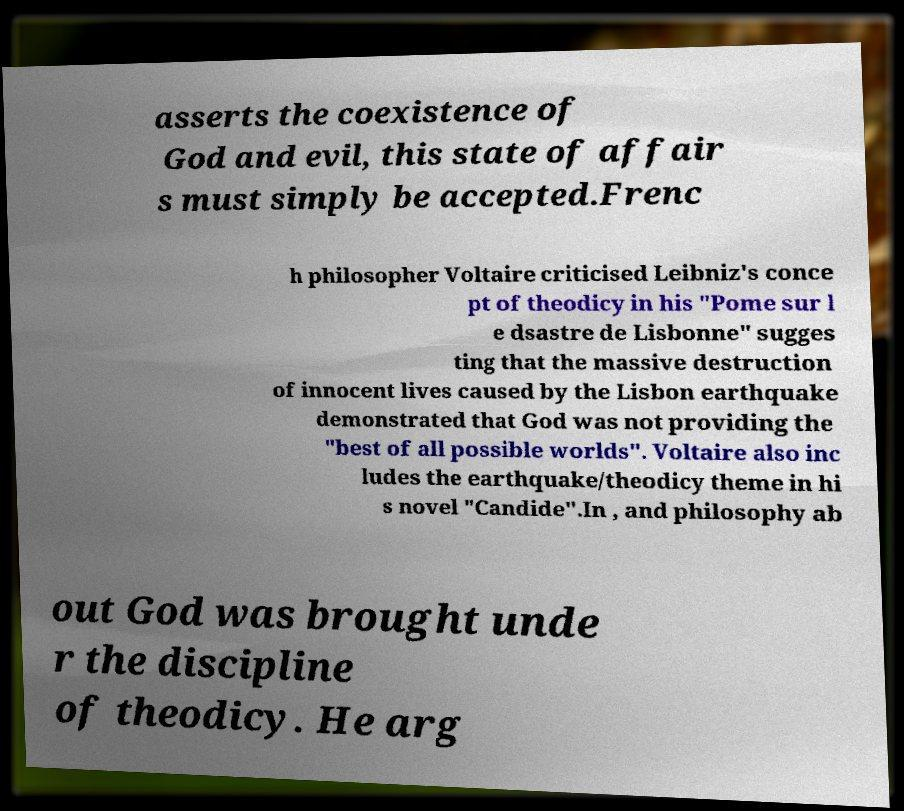Can you read and provide the text displayed in the image?This photo seems to have some interesting text. Can you extract and type it out for me? asserts the coexistence of God and evil, this state of affair s must simply be accepted.Frenc h philosopher Voltaire criticised Leibniz's conce pt of theodicy in his "Pome sur l e dsastre de Lisbonne" sugges ting that the massive destruction of innocent lives caused by the Lisbon earthquake demonstrated that God was not providing the "best of all possible worlds". Voltaire also inc ludes the earthquake/theodicy theme in hi s novel "Candide".In , and philosophy ab out God was brought unde r the discipline of theodicy. He arg 